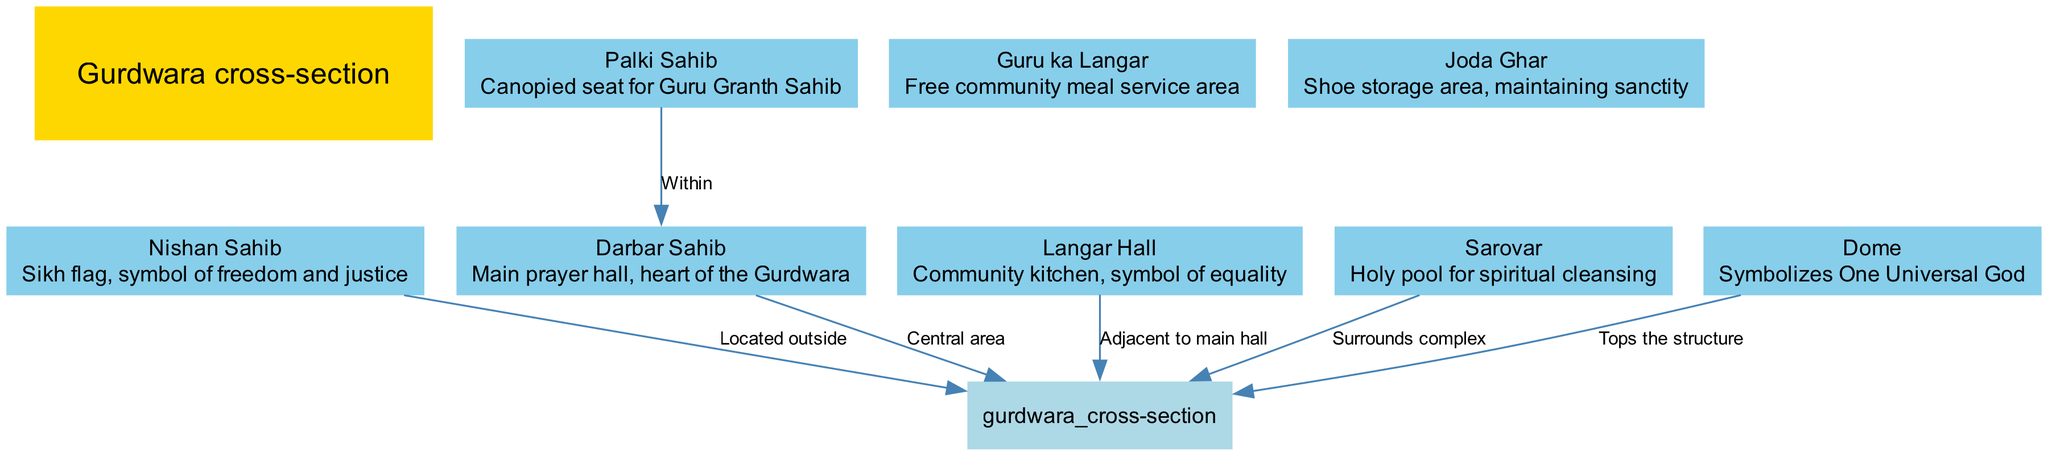What is the main structure of the diagram? The main structure node is labeled "Gurdwara cross-section," which indicates what the entire diagram represents.
Answer: Gurdwara cross-section How many main elements are highlighted in the diagram? The diagram lists eight main elements that are part of the Gurdwara architecture, each described in the data.
Answer: 8 Which element symbolizes freedom and justice? The element labeled "Nishan Sahib" is described as the Sikh flag, representing freedom and justice.
Answer: Nishan Sahib Where is the Langar Hall located in relation to the main hall? The connection indicates that the Langar Hall is "Adjacent to main hall," meaning it is next to the Darbar Sahib.
Answer: Adjacent to main hall What is the purpose of the Sarovar? The Sarovar is described as a "Holy pool for spiritual cleansing," indicating its significance in spiritual practices.
Answer: Holy pool for spiritual cleansing What element sits within the Darbar Sahib? The Palki Sahib is stated to be "Within" the Darbar Sahib, signifying its importance during prayers.
Answer: Palki Sahib How does the dome represent a concept in Sikhism? The dome "Symbolizes One Universal God," indicating its religious significance in representing the oneness of God in Sikh beliefs.
Answer: One Universal God What connects the Nishan Sahib to the Gurdwara structure? The connection is labeled "Located outside," indicating its position relative to the main structure.
Answer: Located outside 